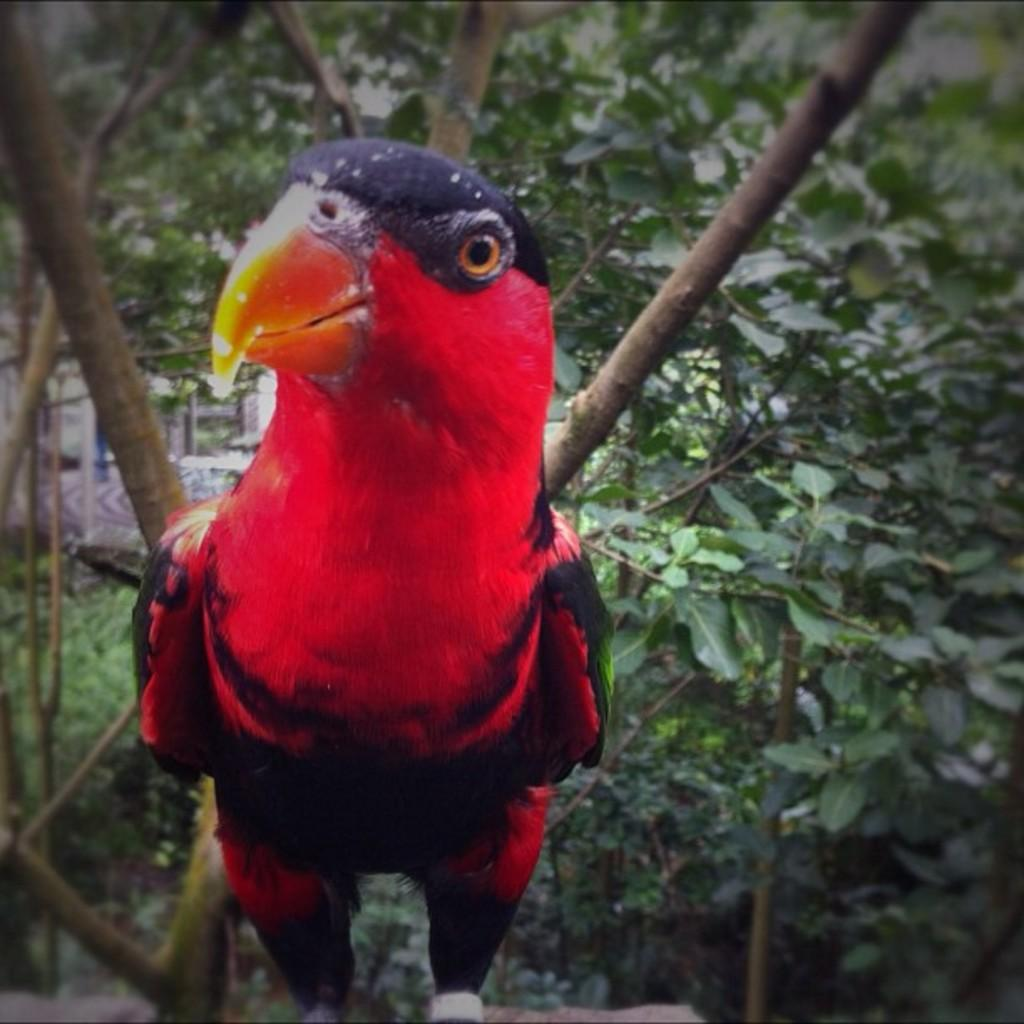What is the main subject of the image? There is a bird in the center of the image. What can be seen in the background of the image? There are trees in the background of the image. What type of flower is being offered by the bird in the image? There is no flower present in the image, and the bird is not offering anything. 